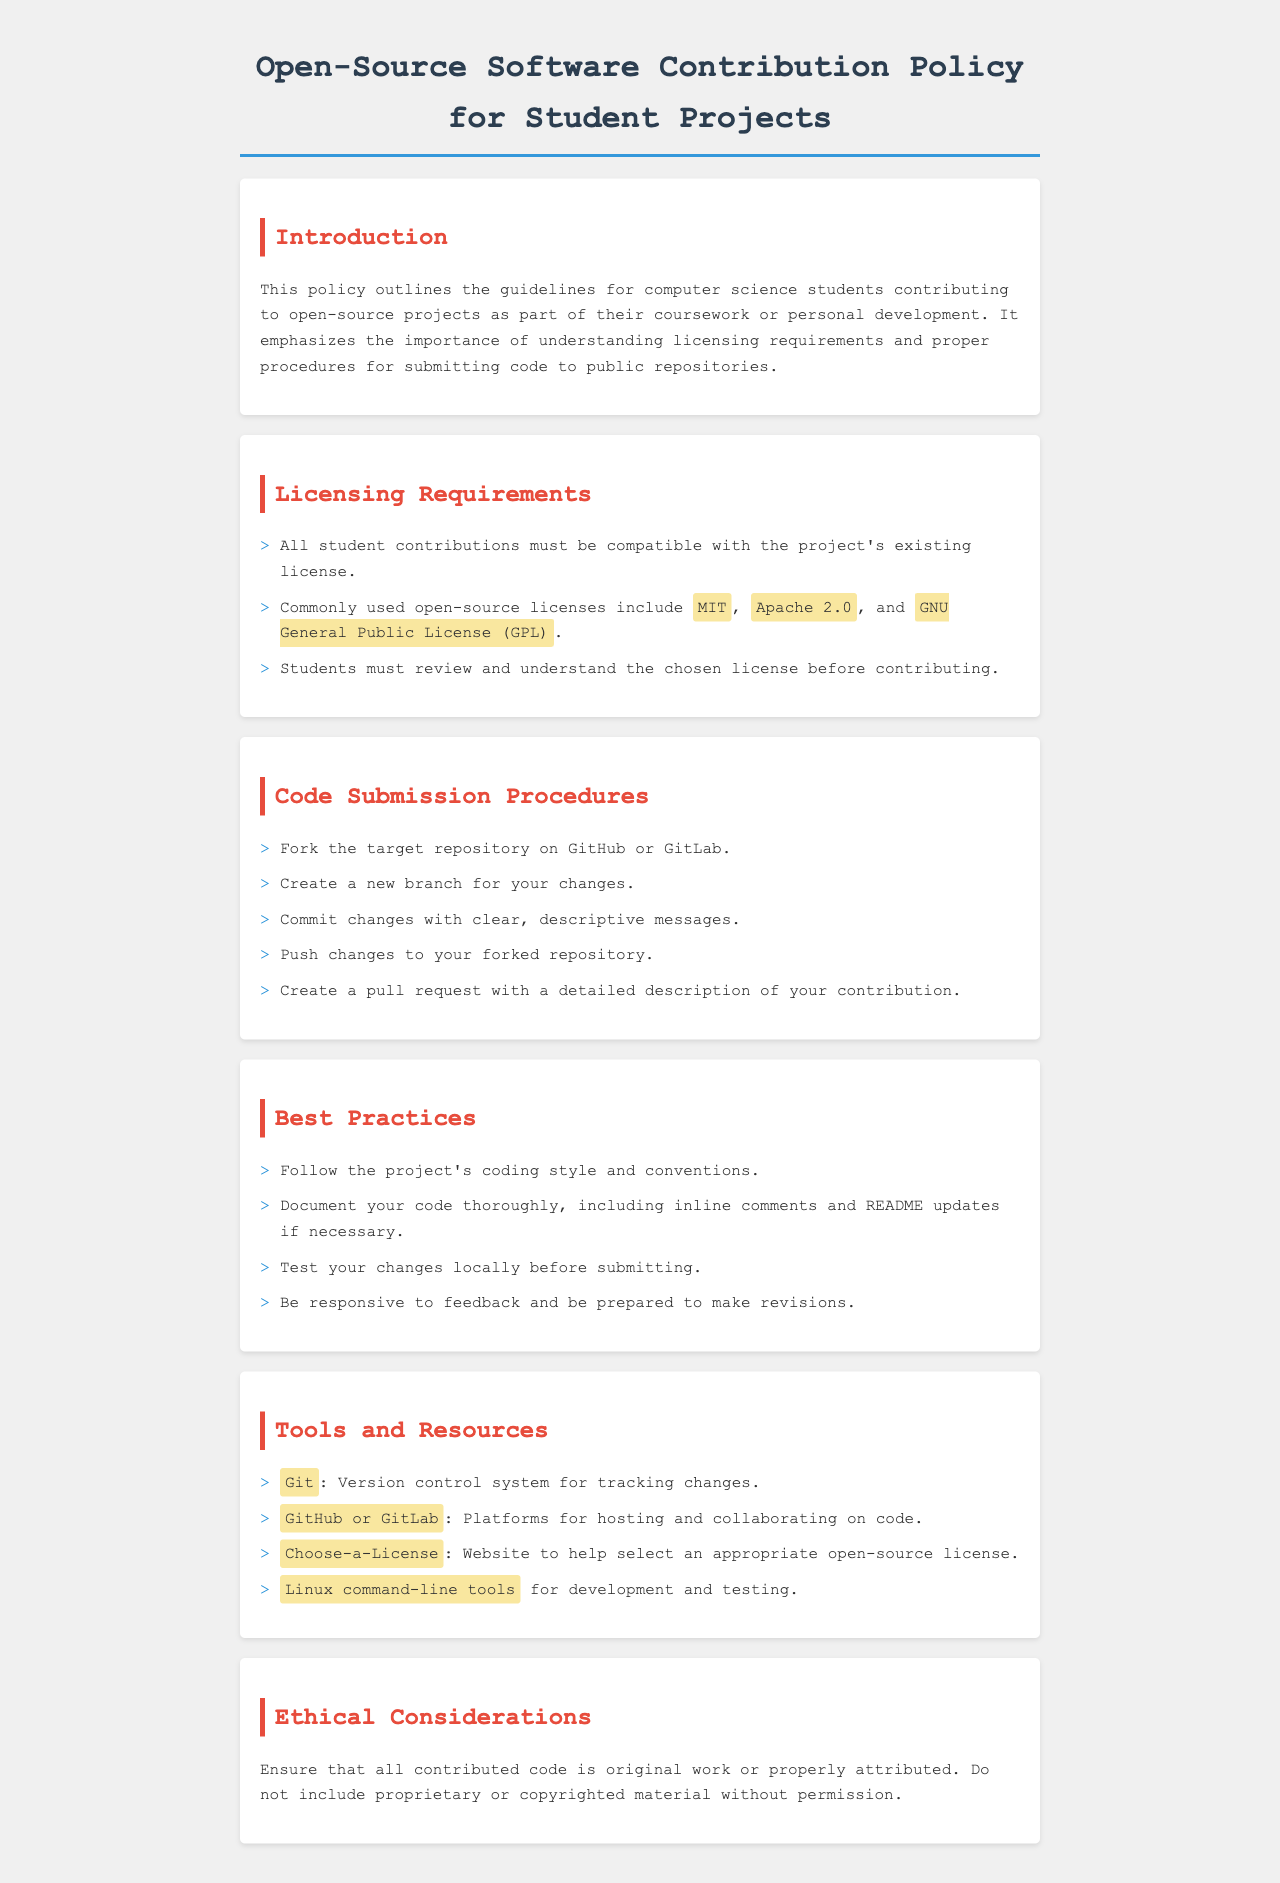What is the title of the policy document? The title is specified in the document's header section.
Answer: Open-Source Software Contribution Policy for Student Projects What is a commonly used open-source license mentioned in the document? The document lists common licenses under the licensing requirements section.
Answer: MIT What are the first two steps in the code submission procedures? The steps are detailed in the 'Code Submission Procedures' section.
Answer: Fork the target repository on GitHub or GitLab, Create a new branch for your changes What should students do before contributing? This is mentioned under licensing requirements.
Answer: Review and understand the chosen license Which platform is suggested for hosting code? The tools and resources section indicates the platform.
Answer: GitHub or GitLab What is a key ethical consideration when contributing code? This is outlined in the 'Ethical Considerations' section of the document.
Answer: Original work or properly attributed How should changes be committed during code submission? This is specified in the code submission procedures.
Answer: Clear, descriptive messages What is one of the best practices mentioned for code submission? Best practices are listed in their own section.
Answer: Document your code thoroughly 